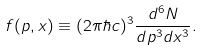Convert formula to latex. <formula><loc_0><loc_0><loc_500><loc_500>f ( { p } , { x } ) \equiv ( 2 \pi \hbar { c } ) ^ { 3 } \frac { d ^ { 6 } N } { d p ^ { 3 } d x ^ { 3 } } .</formula> 